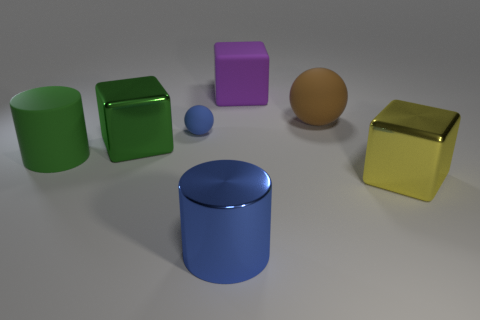Do the big cylinder behind the blue metal object and the cube that is behind the large brown thing have the same material?
Ensure brevity in your answer.  Yes. What shape is the blue thing in front of the big shiny thing on the right side of the purple matte thing?
Give a very brief answer. Cylinder. There is another large ball that is the same material as the blue sphere; what is its color?
Your response must be concise. Brown. Is the matte cylinder the same color as the small object?
Your response must be concise. No. The brown rubber thing that is the same size as the yellow shiny block is what shape?
Your response must be concise. Sphere. How big is the purple matte cube?
Your answer should be compact. Large. There is a cylinder that is behind the big yellow block; is it the same size as the shiny block on the right side of the small blue ball?
Offer a very short reply. Yes. The large metallic block that is in front of the big metallic block left of the blue shiny object is what color?
Your answer should be very brief. Yellow. There is a yellow object that is the same size as the brown sphere; what material is it?
Your answer should be very brief. Metal. How many matte objects are either large blue things or small purple cubes?
Provide a short and direct response. 0. 